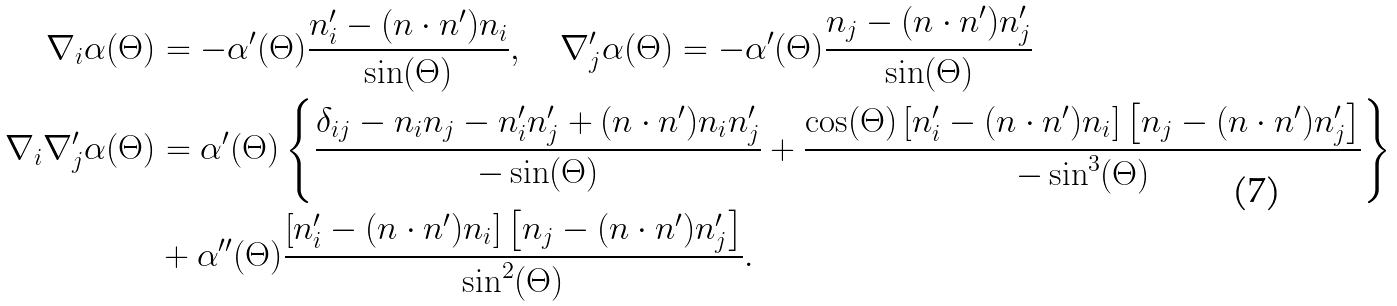Convert formula to latex. <formula><loc_0><loc_0><loc_500><loc_500>\nabla _ { i } \alpha ( \Theta ) & = - \alpha ^ { \prime } ( \Theta ) \frac { n ^ { \prime } _ { i } - ( n \cdot n ^ { \prime } ) n _ { i } } { \sin ( \Theta ) } , \quad \nabla ^ { \prime } _ { j } \alpha ( \Theta ) = - \alpha ^ { \prime } ( \Theta ) \frac { n _ { j } - ( n \cdot n ^ { \prime } ) n ^ { \prime } _ { j } } { \sin ( \Theta ) } \\ \nabla _ { i } \nabla ^ { \prime } _ { j } \alpha ( \Theta ) & = \alpha ^ { \prime } ( \Theta ) \left \{ \frac { \delta _ { i j } - n _ { i } n _ { j } - n ^ { \prime } _ { i } n ^ { \prime } _ { j } + ( n \cdot n ^ { \prime } ) n _ { i } n ^ { \prime } _ { j } } { - \sin ( \Theta ) } + \frac { \cos ( \Theta ) \left [ n ^ { \prime } _ { i } - ( n \cdot n ^ { \prime } ) n _ { i } \right ] \left [ n _ { j } - ( n \cdot n ^ { \prime } ) n ^ { \prime } _ { j } \right ] } { - \sin ^ { 3 } ( \Theta ) } \right \} \\ & + \alpha ^ { \prime \prime } ( \Theta ) \frac { \left [ n ^ { \prime } _ { i } - ( n \cdot n ^ { \prime } ) n _ { i } \right ] \left [ n _ { j } - ( n \cdot n ^ { \prime } ) n ^ { \prime } _ { j } \right ] } { \sin ^ { 2 } ( \Theta ) } .</formula> 